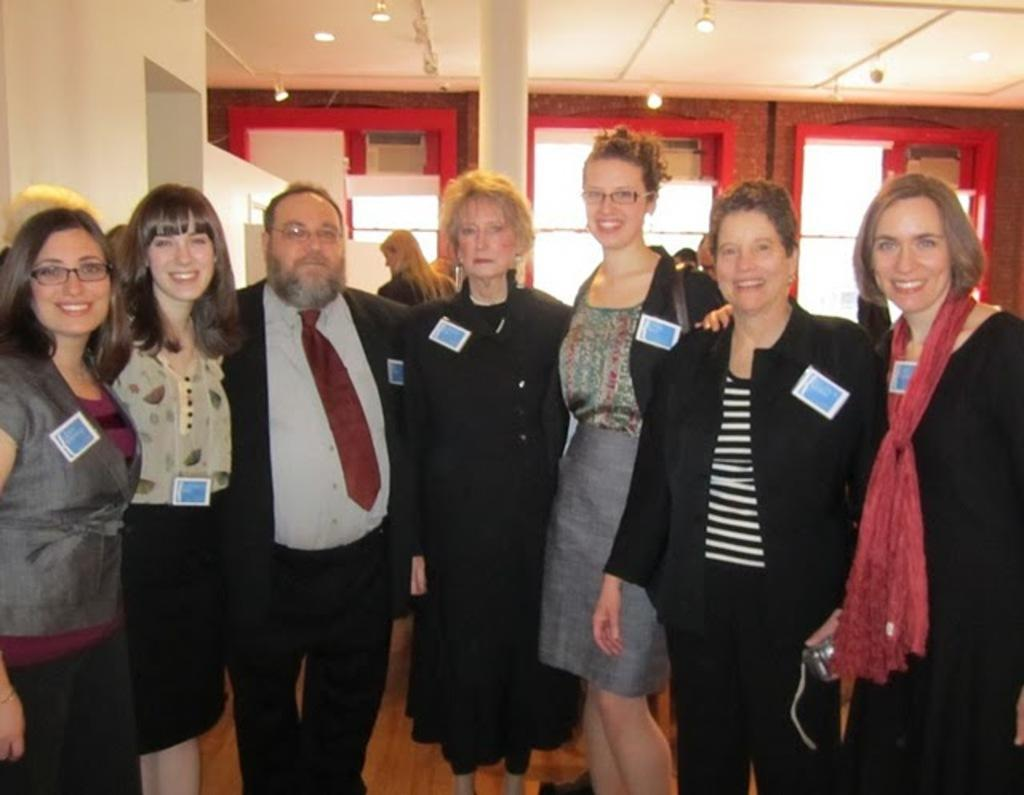What is the main subject in the foreground of the image? There is a group of people in the foreground of the image. What is the surface on which the people are standing? The people are standing on the floor. What can be seen in the background of the image? There is a wall, doors, a pillar, and a rooftop visible in the background of the image. What type of location is depicted in the image? The image is taken in a hall. What type of prison can be seen in the image? There is no prison present in the image; it depicts a group of people in a hall. What kind of machine is being used by the people in the image? There is no machine visible in the image; the people are simply standing in a hall. 